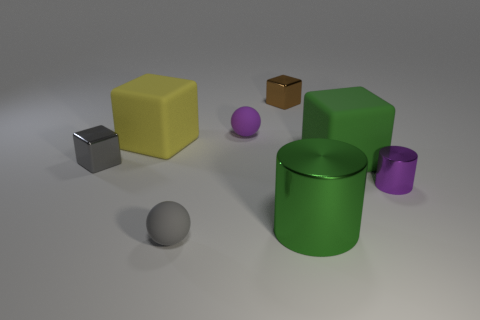There is a brown shiny object that is the same size as the gray block; what is its shape?
Give a very brief answer. Cube. Does the matte object that is to the right of the green metallic object have the same size as the purple matte sphere?
Your answer should be compact. No. There is a cylinder that is the same size as the gray rubber thing; what is it made of?
Ensure brevity in your answer.  Metal. There is a big green shiny cylinder in front of the purple ball behind the big green matte thing; is there a large thing that is in front of it?
Your response must be concise. No. Do the large block right of the purple matte ball and the cylinder in front of the tiny cylinder have the same color?
Your answer should be very brief. Yes. Are there any tiny shiny objects?
Offer a terse response. Yes. What is the size of the matte cube right of the gray rubber sphere that is in front of the shiny cylinder to the left of the small cylinder?
Your answer should be compact. Large. There is a tiny gray metallic object; is its shape the same as the large green thing that is behind the purple cylinder?
Give a very brief answer. Yes. Are there any small objects that have the same color as the small metallic cylinder?
Give a very brief answer. Yes. How many blocks are brown things or big yellow rubber objects?
Your answer should be compact. 2. 